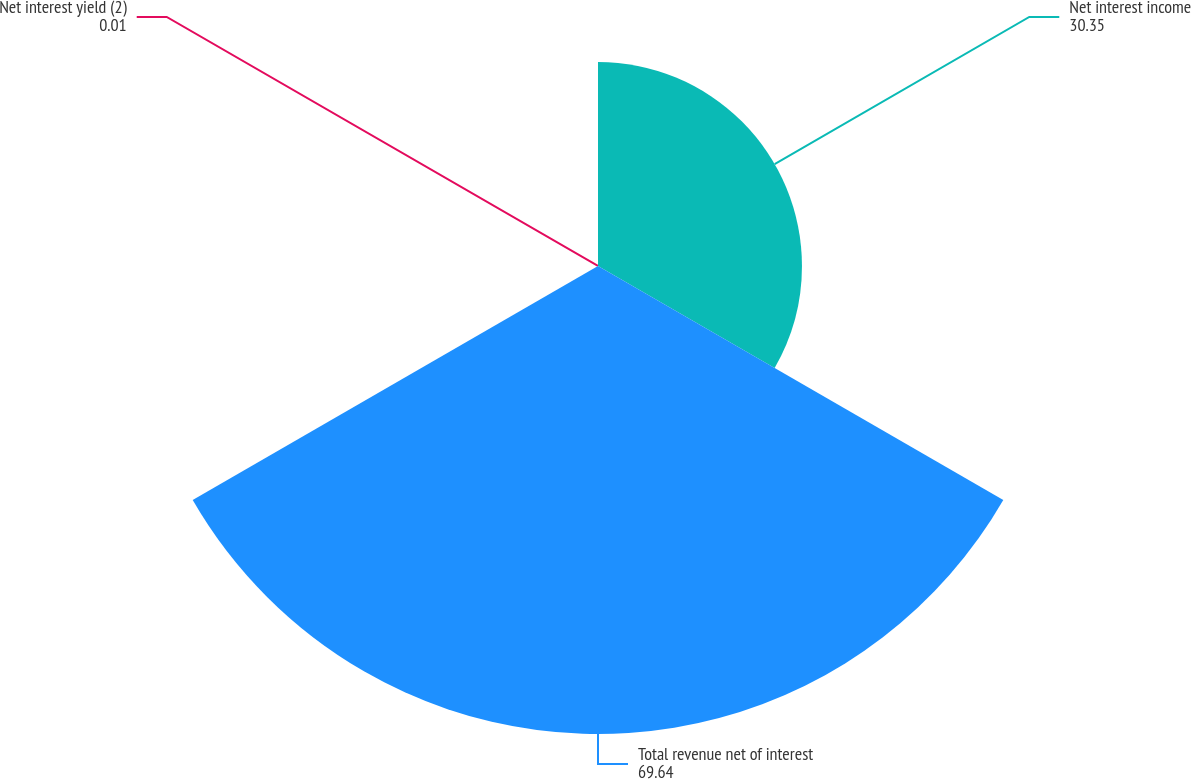Convert chart. <chart><loc_0><loc_0><loc_500><loc_500><pie_chart><fcel>Net interest income<fcel>Total revenue net of interest<fcel>Net interest yield (2)<nl><fcel>30.35%<fcel>69.64%<fcel>0.01%<nl></chart> 